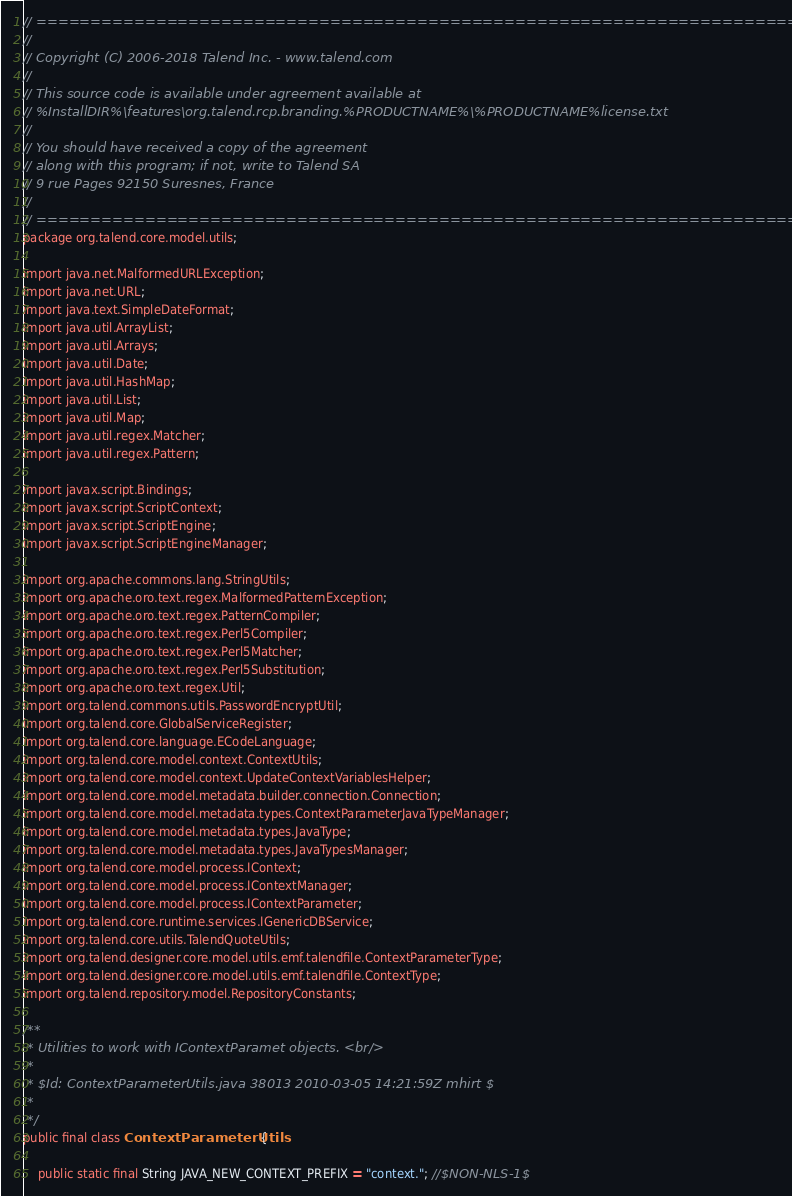Convert code to text. <code><loc_0><loc_0><loc_500><loc_500><_Java_>// ============================================================================
//
// Copyright (C) 2006-2018 Talend Inc. - www.talend.com
//
// This source code is available under agreement available at
// %InstallDIR%\features\org.talend.rcp.branding.%PRODUCTNAME%\%PRODUCTNAME%license.txt
//
// You should have received a copy of the agreement
// along with this program; if not, write to Talend SA
// 9 rue Pages 92150 Suresnes, France
//
// ============================================================================
package org.talend.core.model.utils;

import java.net.MalformedURLException;
import java.net.URL;
import java.text.SimpleDateFormat;
import java.util.ArrayList;
import java.util.Arrays;
import java.util.Date;
import java.util.HashMap;
import java.util.List;
import java.util.Map;
import java.util.regex.Matcher;
import java.util.regex.Pattern;

import javax.script.Bindings;
import javax.script.ScriptContext;
import javax.script.ScriptEngine;
import javax.script.ScriptEngineManager;

import org.apache.commons.lang.StringUtils;
import org.apache.oro.text.regex.MalformedPatternException;
import org.apache.oro.text.regex.PatternCompiler;
import org.apache.oro.text.regex.Perl5Compiler;
import org.apache.oro.text.regex.Perl5Matcher;
import org.apache.oro.text.regex.Perl5Substitution;
import org.apache.oro.text.regex.Util;
import org.talend.commons.utils.PasswordEncryptUtil;
import org.talend.core.GlobalServiceRegister;
import org.talend.core.language.ECodeLanguage;
import org.talend.core.model.context.ContextUtils;
import org.talend.core.model.context.UpdateContextVariablesHelper;
import org.talend.core.model.metadata.builder.connection.Connection;
import org.talend.core.model.metadata.types.ContextParameterJavaTypeManager;
import org.talend.core.model.metadata.types.JavaType;
import org.talend.core.model.metadata.types.JavaTypesManager;
import org.talend.core.model.process.IContext;
import org.talend.core.model.process.IContextManager;
import org.talend.core.model.process.IContextParameter;
import org.talend.core.runtime.services.IGenericDBService;
import org.talend.core.utils.TalendQuoteUtils;
import org.talend.designer.core.model.utils.emf.talendfile.ContextParameterType;
import org.talend.designer.core.model.utils.emf.talendfile.ContextType;
import org.talend.repository.model.RepositoryConstants;

/**
 * Utilities to work with IContextParamet objects. <br/>
 * 
 * $Id: ContextParameterUtils.java 38013 2010-03-05 14:21:59Z mhirt $
 * 
 */
public final class ContextParameterUtils {

    public static final String JAVA_NEW_CONTEXT_PREFIX = "context."; //$NON-NLS-1$
</code> 